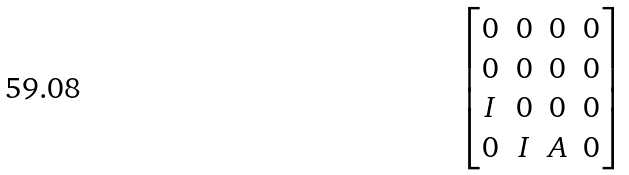Convert formula to latex. <formula><loc_0><loc_0><loc_500><loc_500>\begin{bmatrix} 0 & 0 & 0 & 0 \\ 0 & 0 & 0 & 0 \\ I & 0 & 0 & 0 \\ 0 & I & A & 0 \end{bmatrix}</formula> 